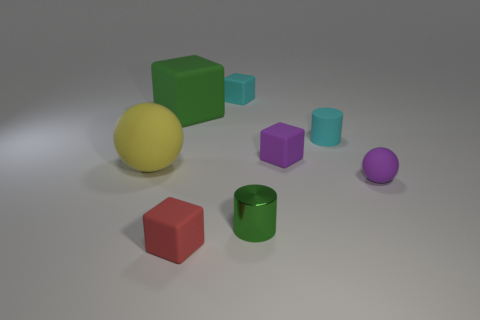Add 2 tiny matte spheres. How many objects exist? 10 Subtract all balls. How many objects are left? 6 Subtract 1 green cylinders. How many objects are left? 7 Subtract all large green matte cubes. Subtract all green things. How many objects are left? 5 Add 8 purple matte objects. How many purple matte objects are left? 10 Add 4 brown rubber balls. How many brown rubber balls exist? 4 